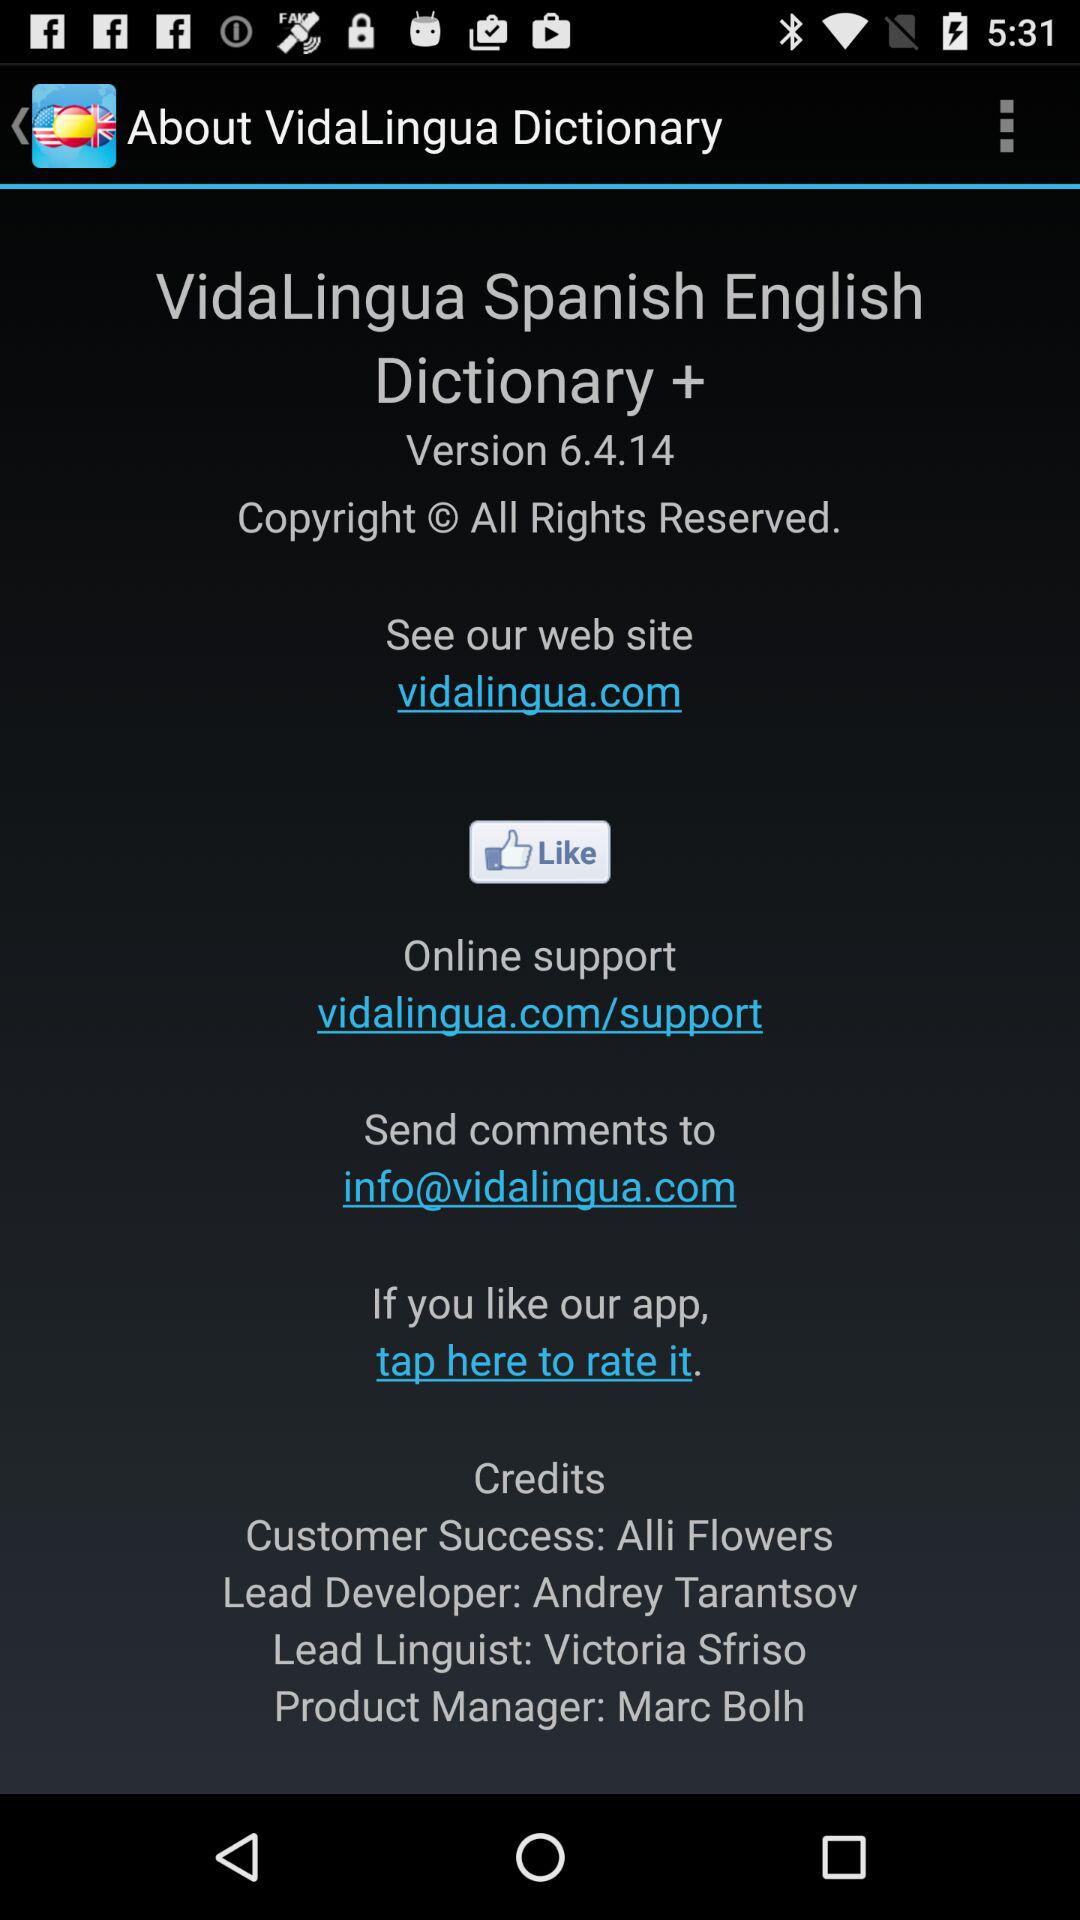What is the web site? The web site is vidalingua.com. 